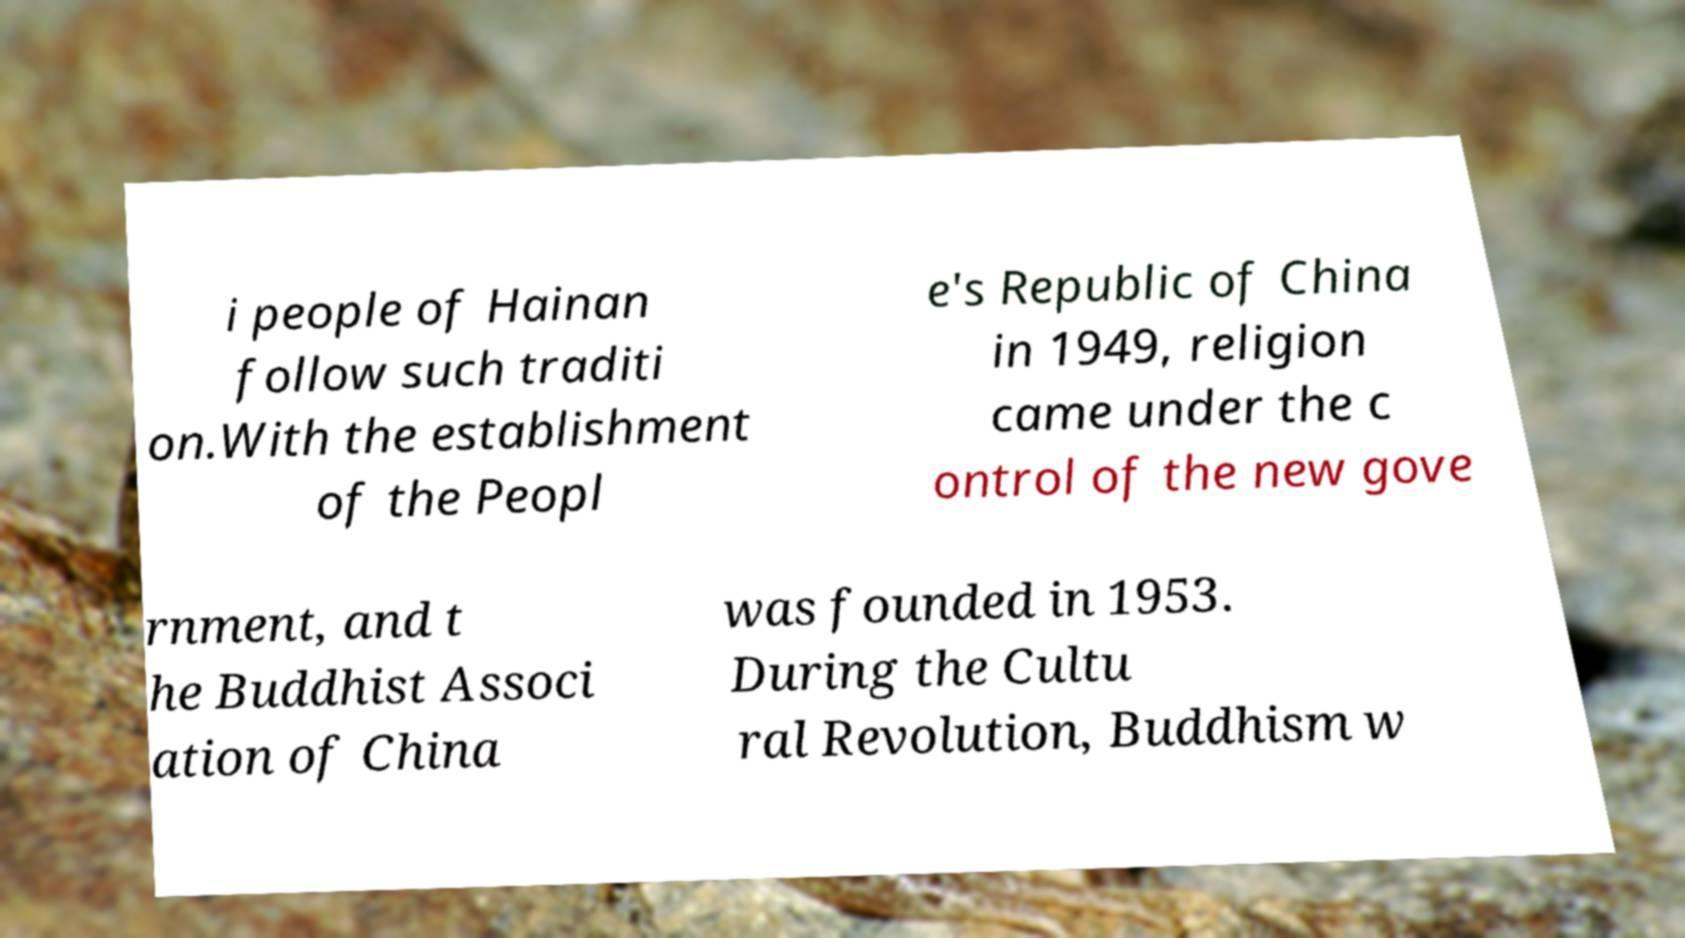Can you read and provide the text displayed in the image?This photo seems to have some interesting text. Can you extract and type it out for me? i people of Hainan follow such traditi on.With the establishment of the Peopl e's Republic of China in 1949, religion came under the c ontrol of the new gove rnment, and t he Buddhist Associ ation of China was founded in 1953. During the Cultu ral Revolution, Buddhism w 